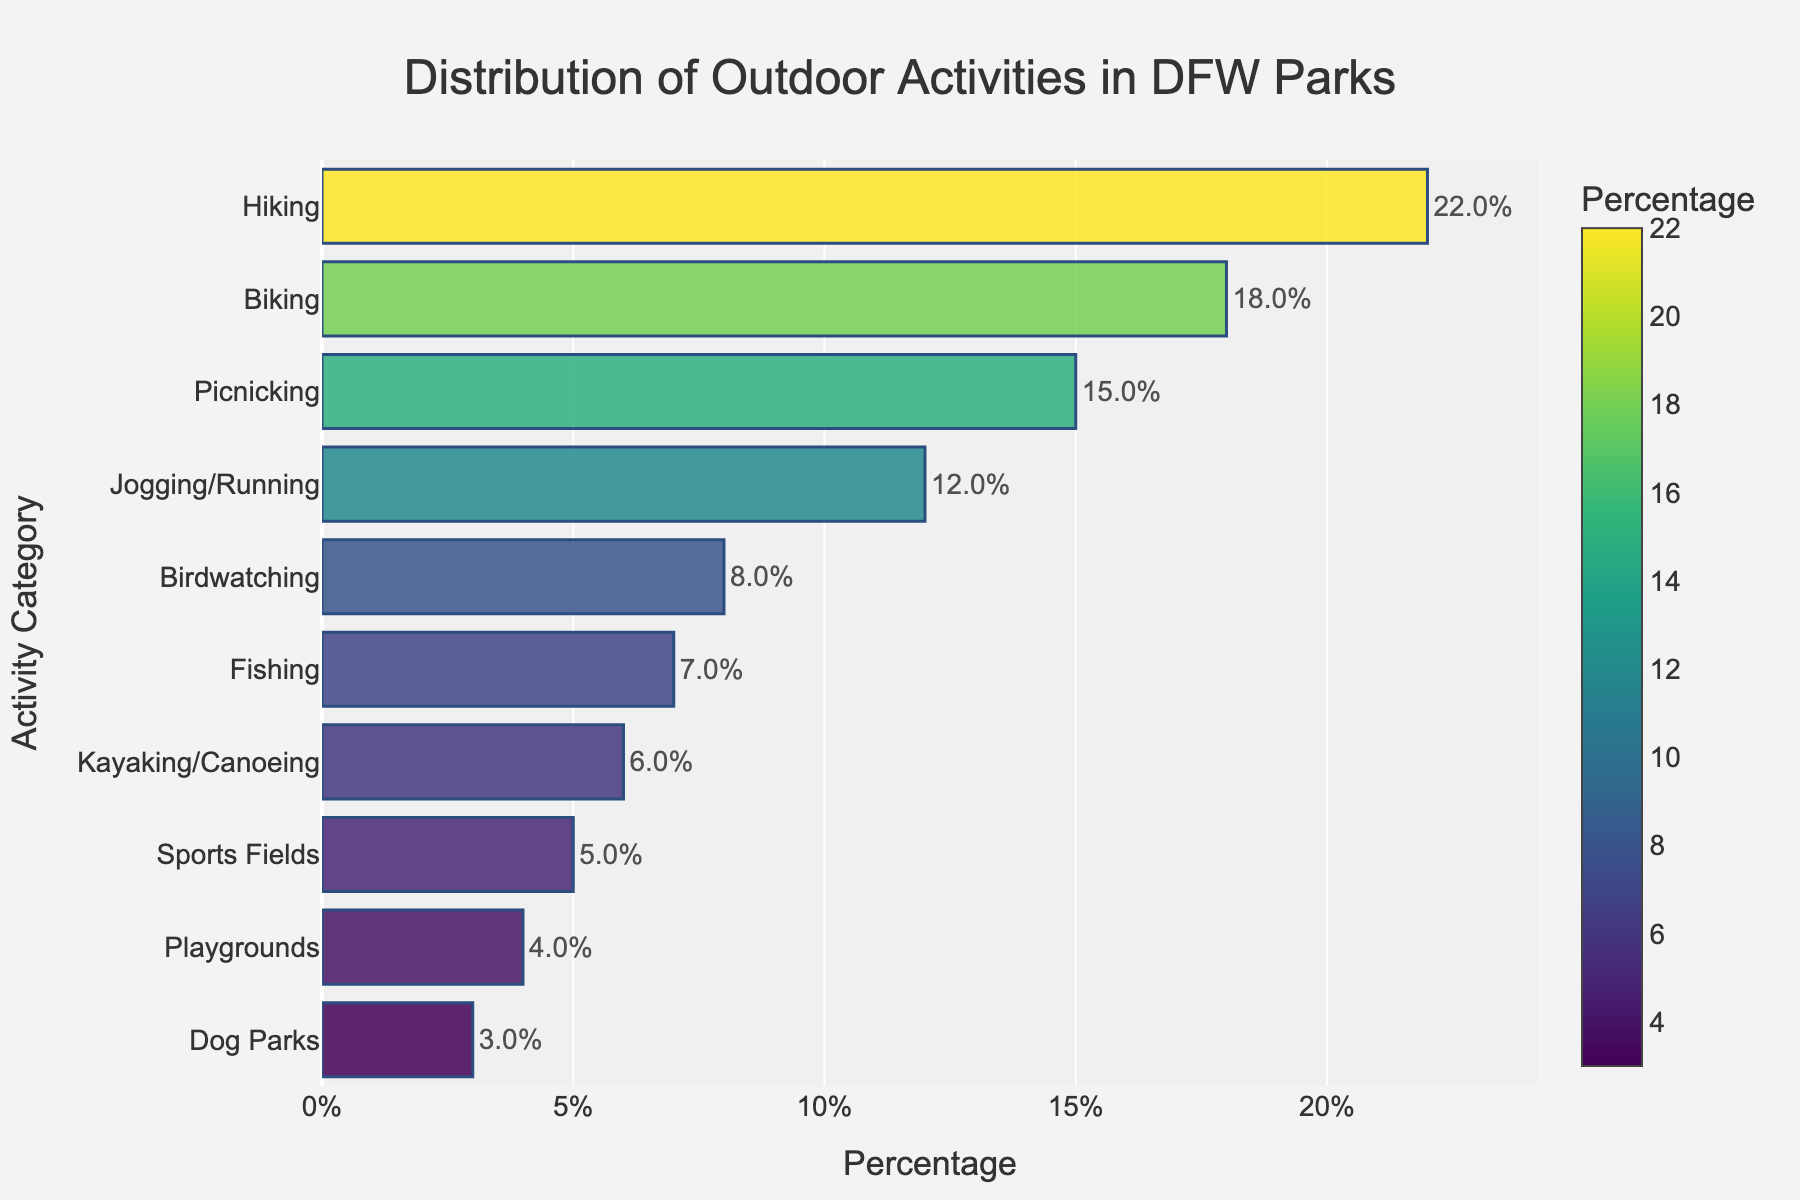Which outdoor activity is most popular in DFW parks? From the bar chart, the tallest bar represents Hiking with the highest percentage, which makes it the most popular activity.
Answer: Hiking Which outdoor activities have percentages greater than 15%? Analyzing the bar chart, the activities with bars extending beyond 15% are Hiking and Biking.
Answer: Hiking and Biking What is the combined percentage of Fishing and Kayaking/Canoeing activities? From the chart, Fishing has 7% and Kayaking/Canoeing has 6%. Adding these together: 7% + 6% = 13%.
Answer: 13% How does the percentage of Jogging/Running compare to Birdwatching? Observing the bar chart, Jogging/Running has a taller bar than Birdwatching, with percentages of 12% and 8% respectively. Thus, Jogging/Running has a higher percentage.
Answer: Jogging/Running has a higher percentage If you combine the percentages of Picnicking, Dog Parks, and Playgrounds, what is the total? Picnicking is 15%, Dog Parks is 3%, and Playgrounds is 4%. Adding these: 15% + 3% + 4% = 22%.
Answer: 22% What percentage of outdoor activities is accounted for by Sports Fields and Playgrounds combined? From the chart, Sports Fields account for 5% and Playgrounds for 4%. Summing them up: 5% + 4% = 9%.
Answer: 9% Compare the percentage of Picnicking with Fishing. Which is higher, and by how much? Referring to the chart, Picnicking has 15% while Fishing has 7%. The difference is 15% - 7% = 8%.
Answer: Picnicking, by 8% Which activities have the lowest representation in the parks? The shortest bars on the chart represent Dog Parks and Playgrounds, with percentages of 3% and 4% respectively.
Answer: Dog Parks and Playgrounds What is the range of percentages among all activities? The highest percentage is Hiking at 22% and the lowest is Dog Parks at 3%. The range is 22% - 3% = 19%.
Answer: 19% How much more popular is Hiking compared to Biking? Hiking has 22% and Biking has 18%. The difference is 22% - 18% = 4%.
Answer: 4% 